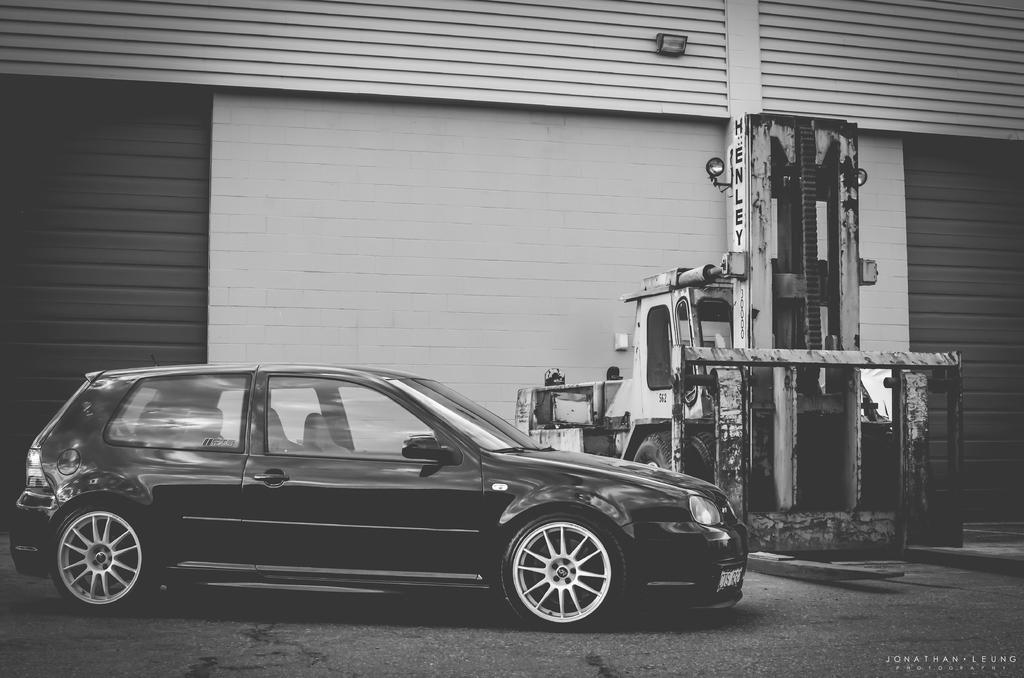What is the main subject in the foreground of the image? There is a car in the foreground of the image. What is the position of the car in relation to the ground? The car is on the ground. What can be seen in the background of the image? There is a vehicle near a wall in the background of the image. Can you describe the wall in the background? There is a wall in the background of the image, and there is a light on top of it. What is the rate at which the camera is capturing images in the image? There is no camera present in the image, so it is not possible to determine the rate at which images are being captured. How many sticks are visible in the image? There are no sticks visible in the image. 